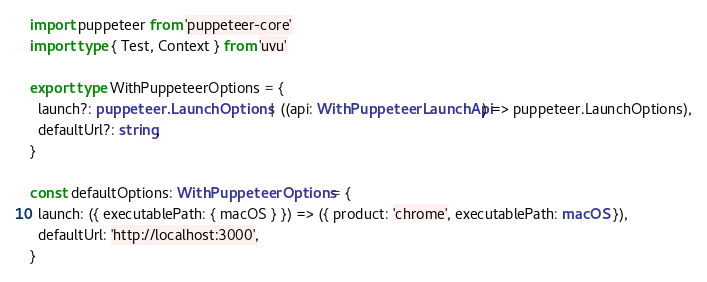<code> <loc_0><loc_0><loc_500><loc_500><_TypeScript_>import puppeteer from 'puppeteer-core'
import type { Test, Context } from 'uvu'

export type WithPuppeteerOptions = {
  launch?: puppeteer.LaunchOptions | ((api: WithPuppeteerLaunchApi) => puppeteer.LaunchOptions),
  defaultUrl?: string,
}

const defaultOptions: WithPuppeteerOptions = {
  launch: ({ executablePath: { macOS } }) => ({ product: 'chrome', executablePath: macOS }),
  defaultUrl: 'http://localhost:3000',
}
</code> 